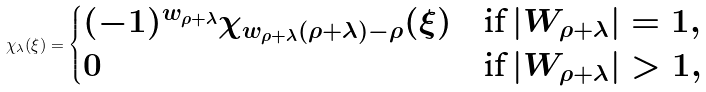<formula> <loc_0><loc_0><loc_500><loc_500>\chi _ { \lambda } ( \xi ) = \begin{cases} ( - 1 ) ^ { w _ { \rho + \lambda } } \chi _ { w _ { \rho + \lambda } ( \rho + \lambda ) - \rho } ( \xi ) & \text {if} \, | W _ { \rho + \lambda } | = 1 , \\ 0 & \text {if} \, | W _ { \rho + \lambda } | > 1 , \end{cases}</formula> 